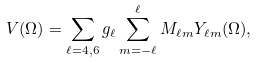Convert formula to latex. <formula><loc_0><loc_0><loc_500><loc_500>V ( \Omega ) = \sum _ { \ell = 4 , 6 } g _ { \ell } \sum _ { m = - \ell } ^ { \ell } M _ { \ell m } Y _ { \ell m } ( \Omega ) ,</formula> 